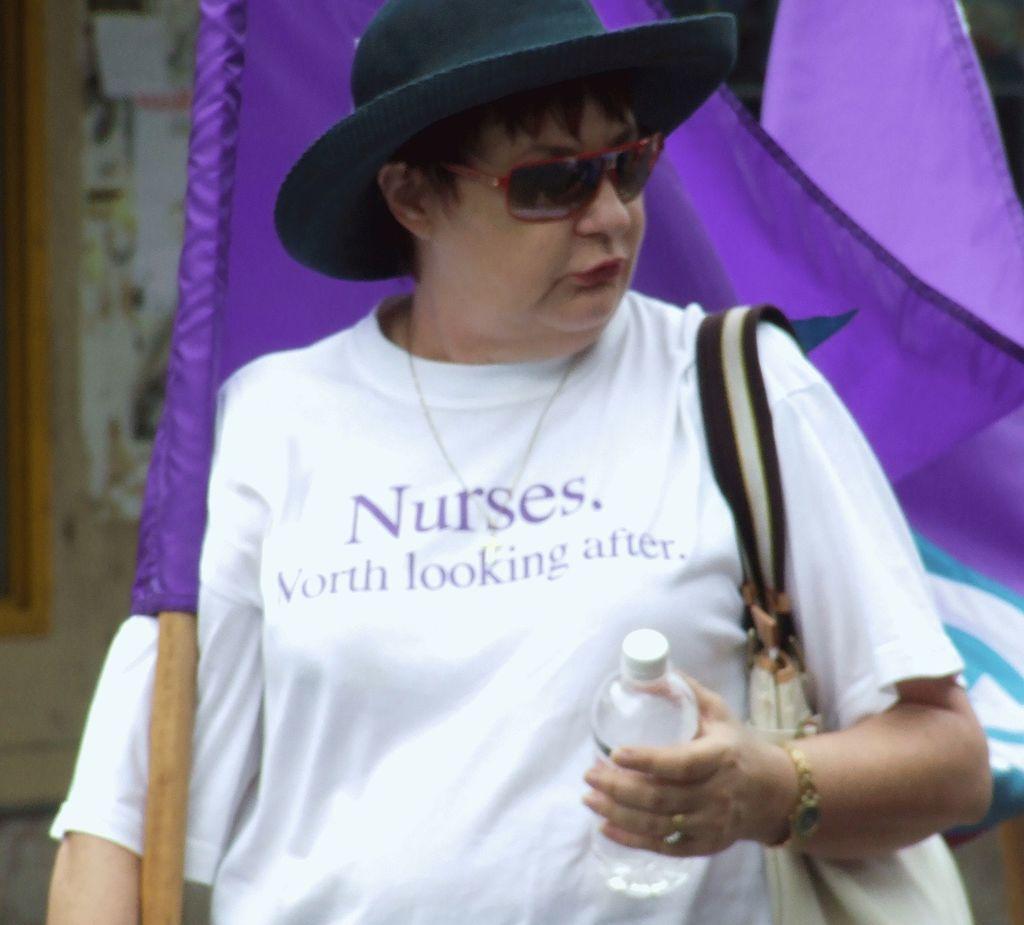In one or two sentences, can you explain what this image depicts? This picture shows a woman holding a water bottle, wearing a spectacles and a hat, walking with a flag in her hand. 